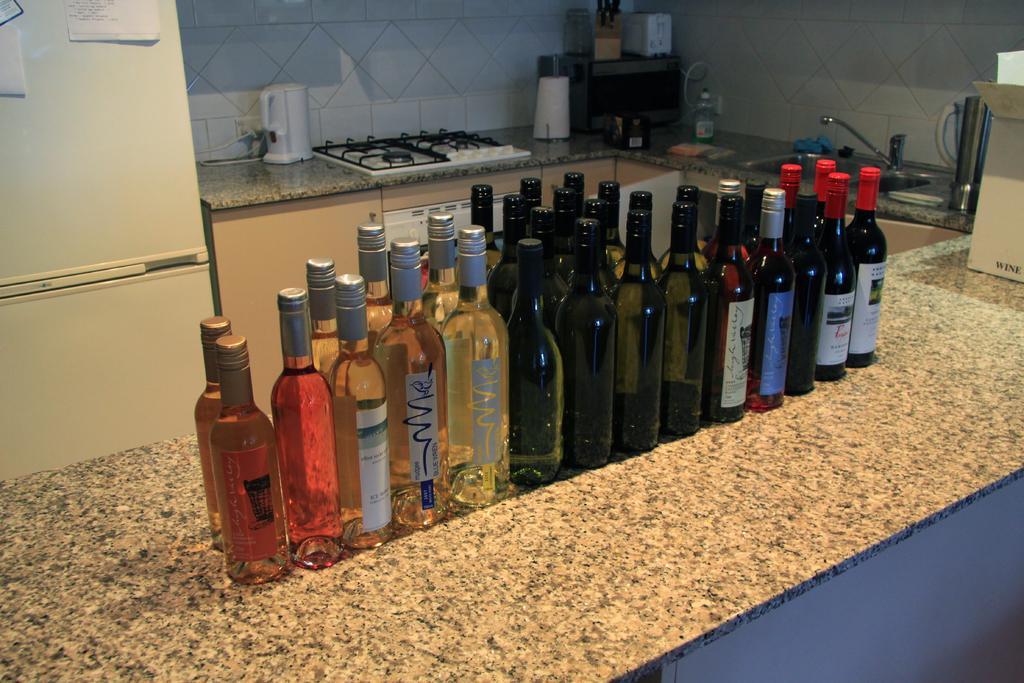Please provide a concise description of this image. In this picture, we see a bunch of wine bottles On the counter top of a kitchen and we see a gas stove and a refrigerator 